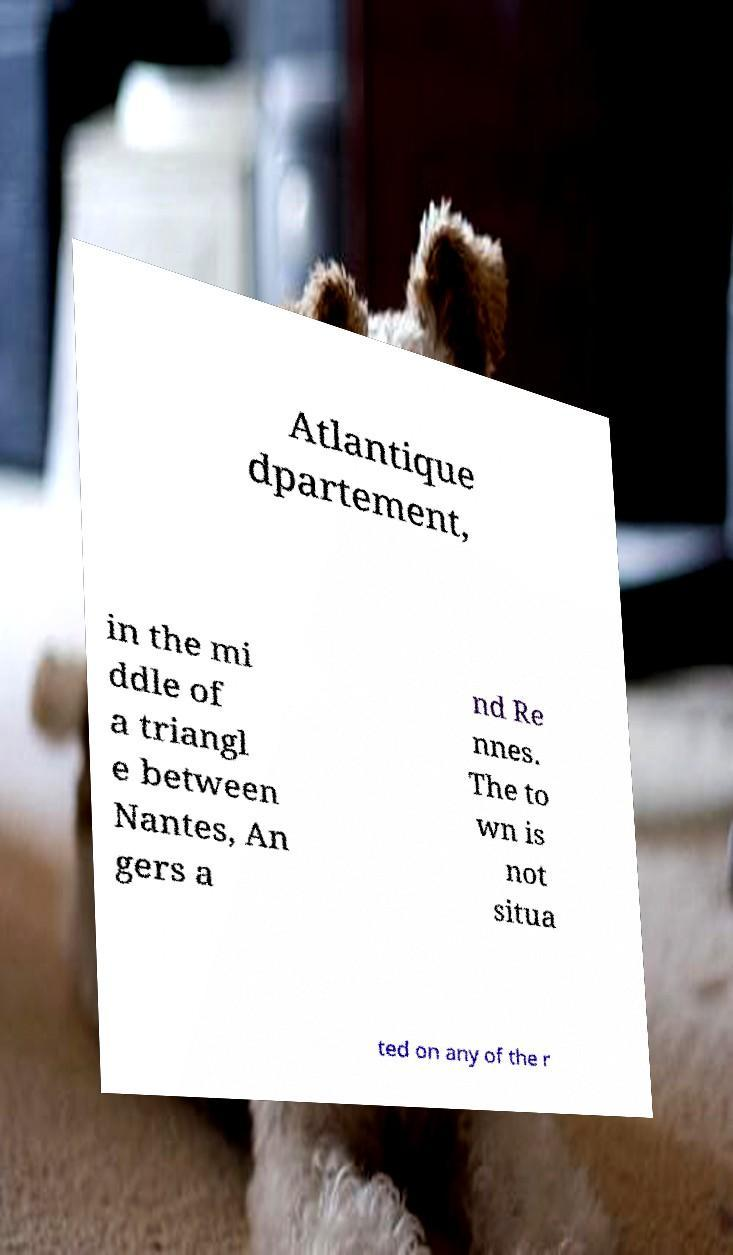Can you read and provide the text displayed in the image?This photo seems to have some interesting text. Can you extract and type it out for me? Atlantique dpartement, in the mi ddle of a triangl e between Nantes, An gers a nd Re nnes. The to wn is not situa ted on any of the r 